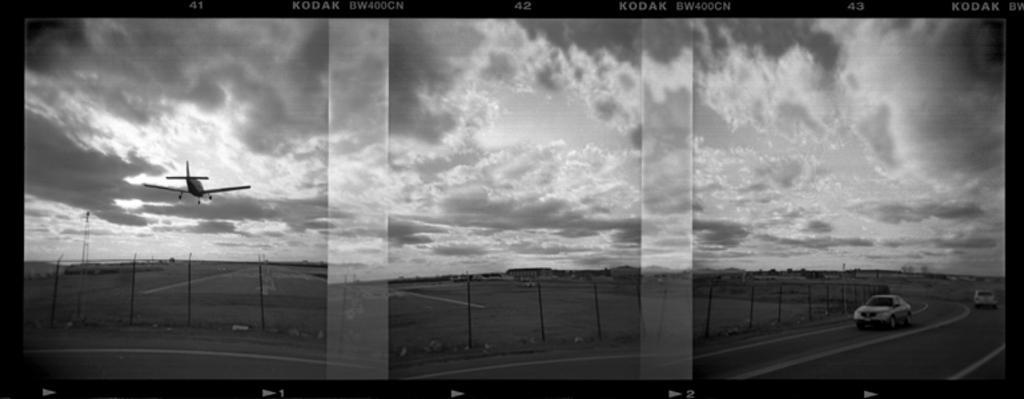<image>
Present a compact description of the photo's key features. three black and white images of a desolate road on KODAK paper 